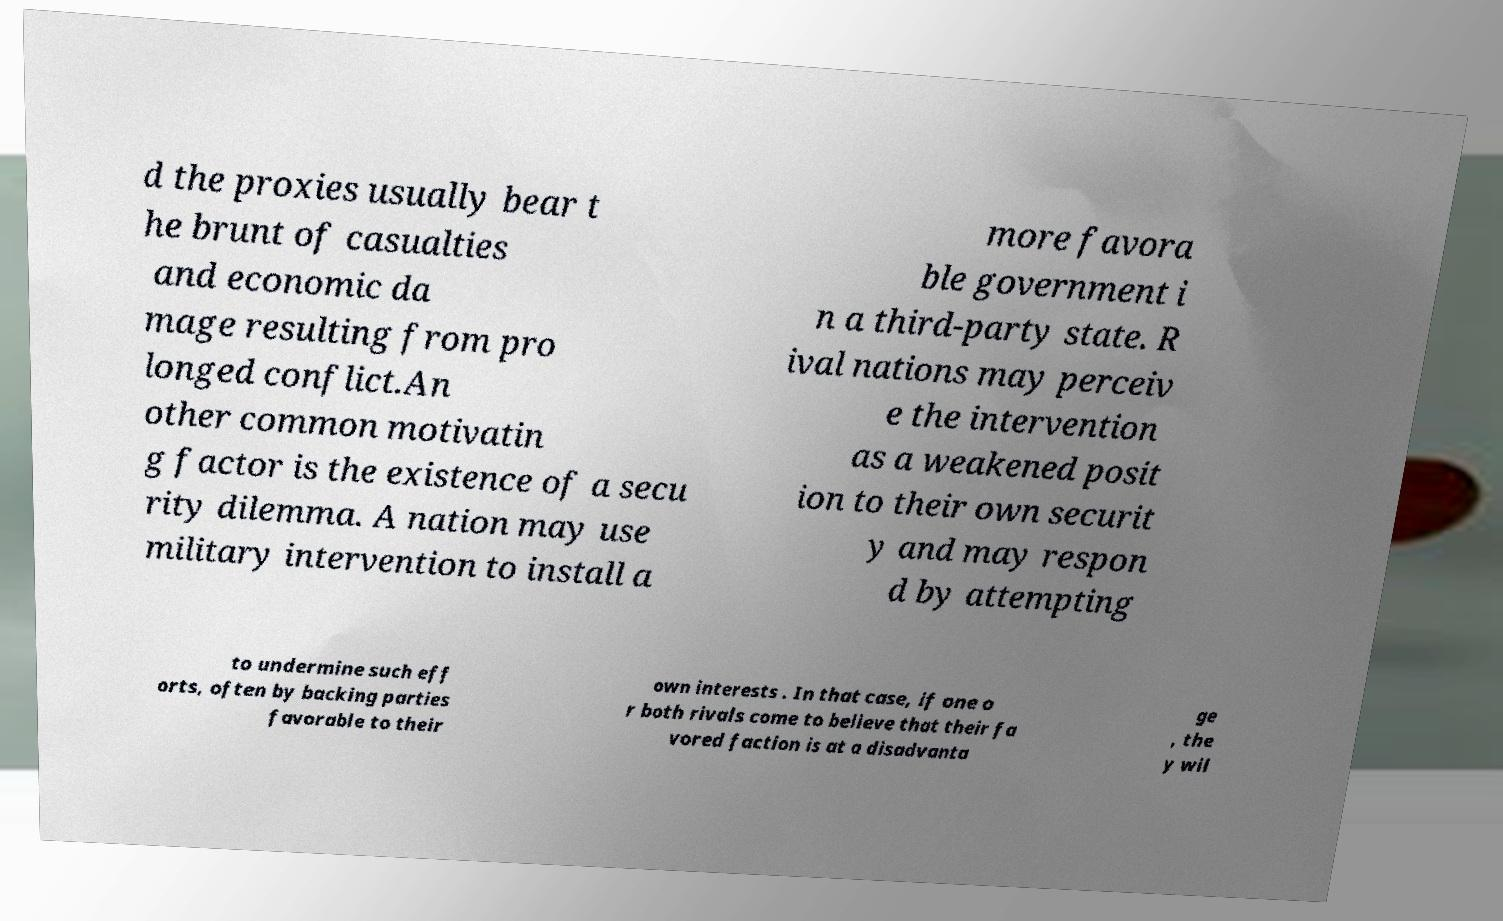I need the written content from this picture converted into text. Can you do that? d the proxies usually bear t he brunt of casualties and economic da mage resulting from pro longed conflict.An other common motivatin g factor is the existence of a secu rity dilemma. A nation may use military intervention to install a more favora ble government i n a third-party state. R ival nations may perceiv e the intervention as a weakened posit ion to their own securit y and may respon d by attempting to undermine such eff orts, often by backing parties favorable to their own interests . In that case, if one o r both rivals come to believe that their fa vored faction is at a disadvanta ge , the y wil 